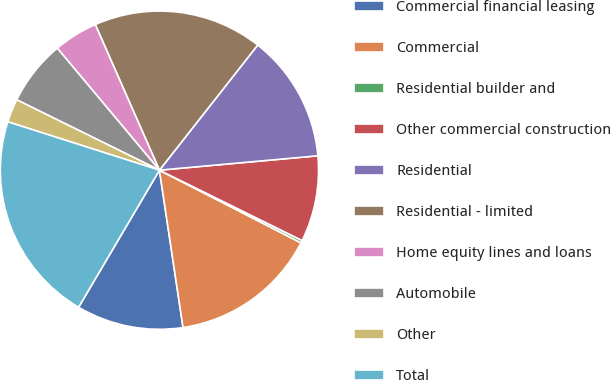Convert chart to OTSL. <chart><loc_0><loc_0><loc_500><loc_500><pie_chart><fcel>Commercial financial leasing<fcel>Commercial<fcel>Residential builder and<fcel>Other commercial construction<fcel>Residential<fcel>Residential - limited<fcel>Home equity lines and loans<fcel>Automobile<fcel>Other<fcel>Total<nl><fcel>10.85%<fcel>15.08%<fcel>0.26%<fcel>8.73%<fcel>12.96%<fcel>17.2%<fcel>4.49%<fcel>6.61%<fcel>2.38%<fcel>21.43%<nl></chart> 